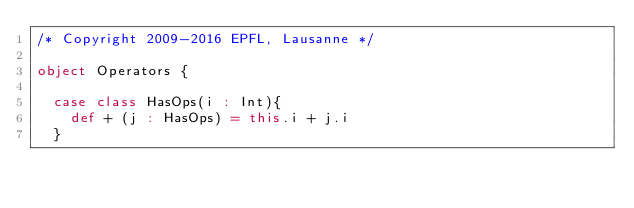Convert code to text. <code><loc_0><loc_0><loc_500><loc_500><_Scala_>/* Copyright 2009-2016 EPFL, Lausanne */

object Operators {
  
  case class HasOps(i : Int){
    def + (j : HasOps) = this.i + j.i
  }
  </code> 